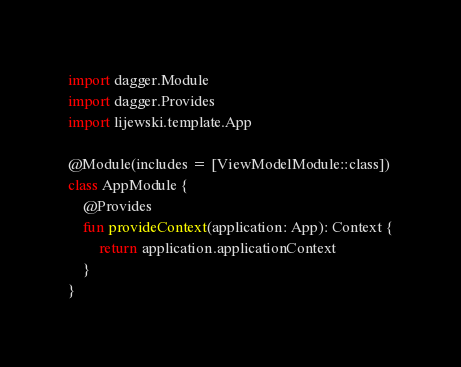<code> <loc_0><loc_0><loc_500><loc_500><_Kotlin_>import dagger.Module
import dagger.Provides
import lijewski.template.App

@Module(includes = [ViewModelModule::class])
class AppModule {
    @Provides
    fun provideContext(application: App): Context {
        return application.applicationContext
    }
}
</code> 